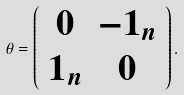<formula> <loc_0><loc_0><loc_500><loc_500>\theta = \left ( \begin{array} { c c } 0 & - { 1 } _ { n } \\ { 1 } _ { n } & 0 \end{array} \right ) .</formula> 